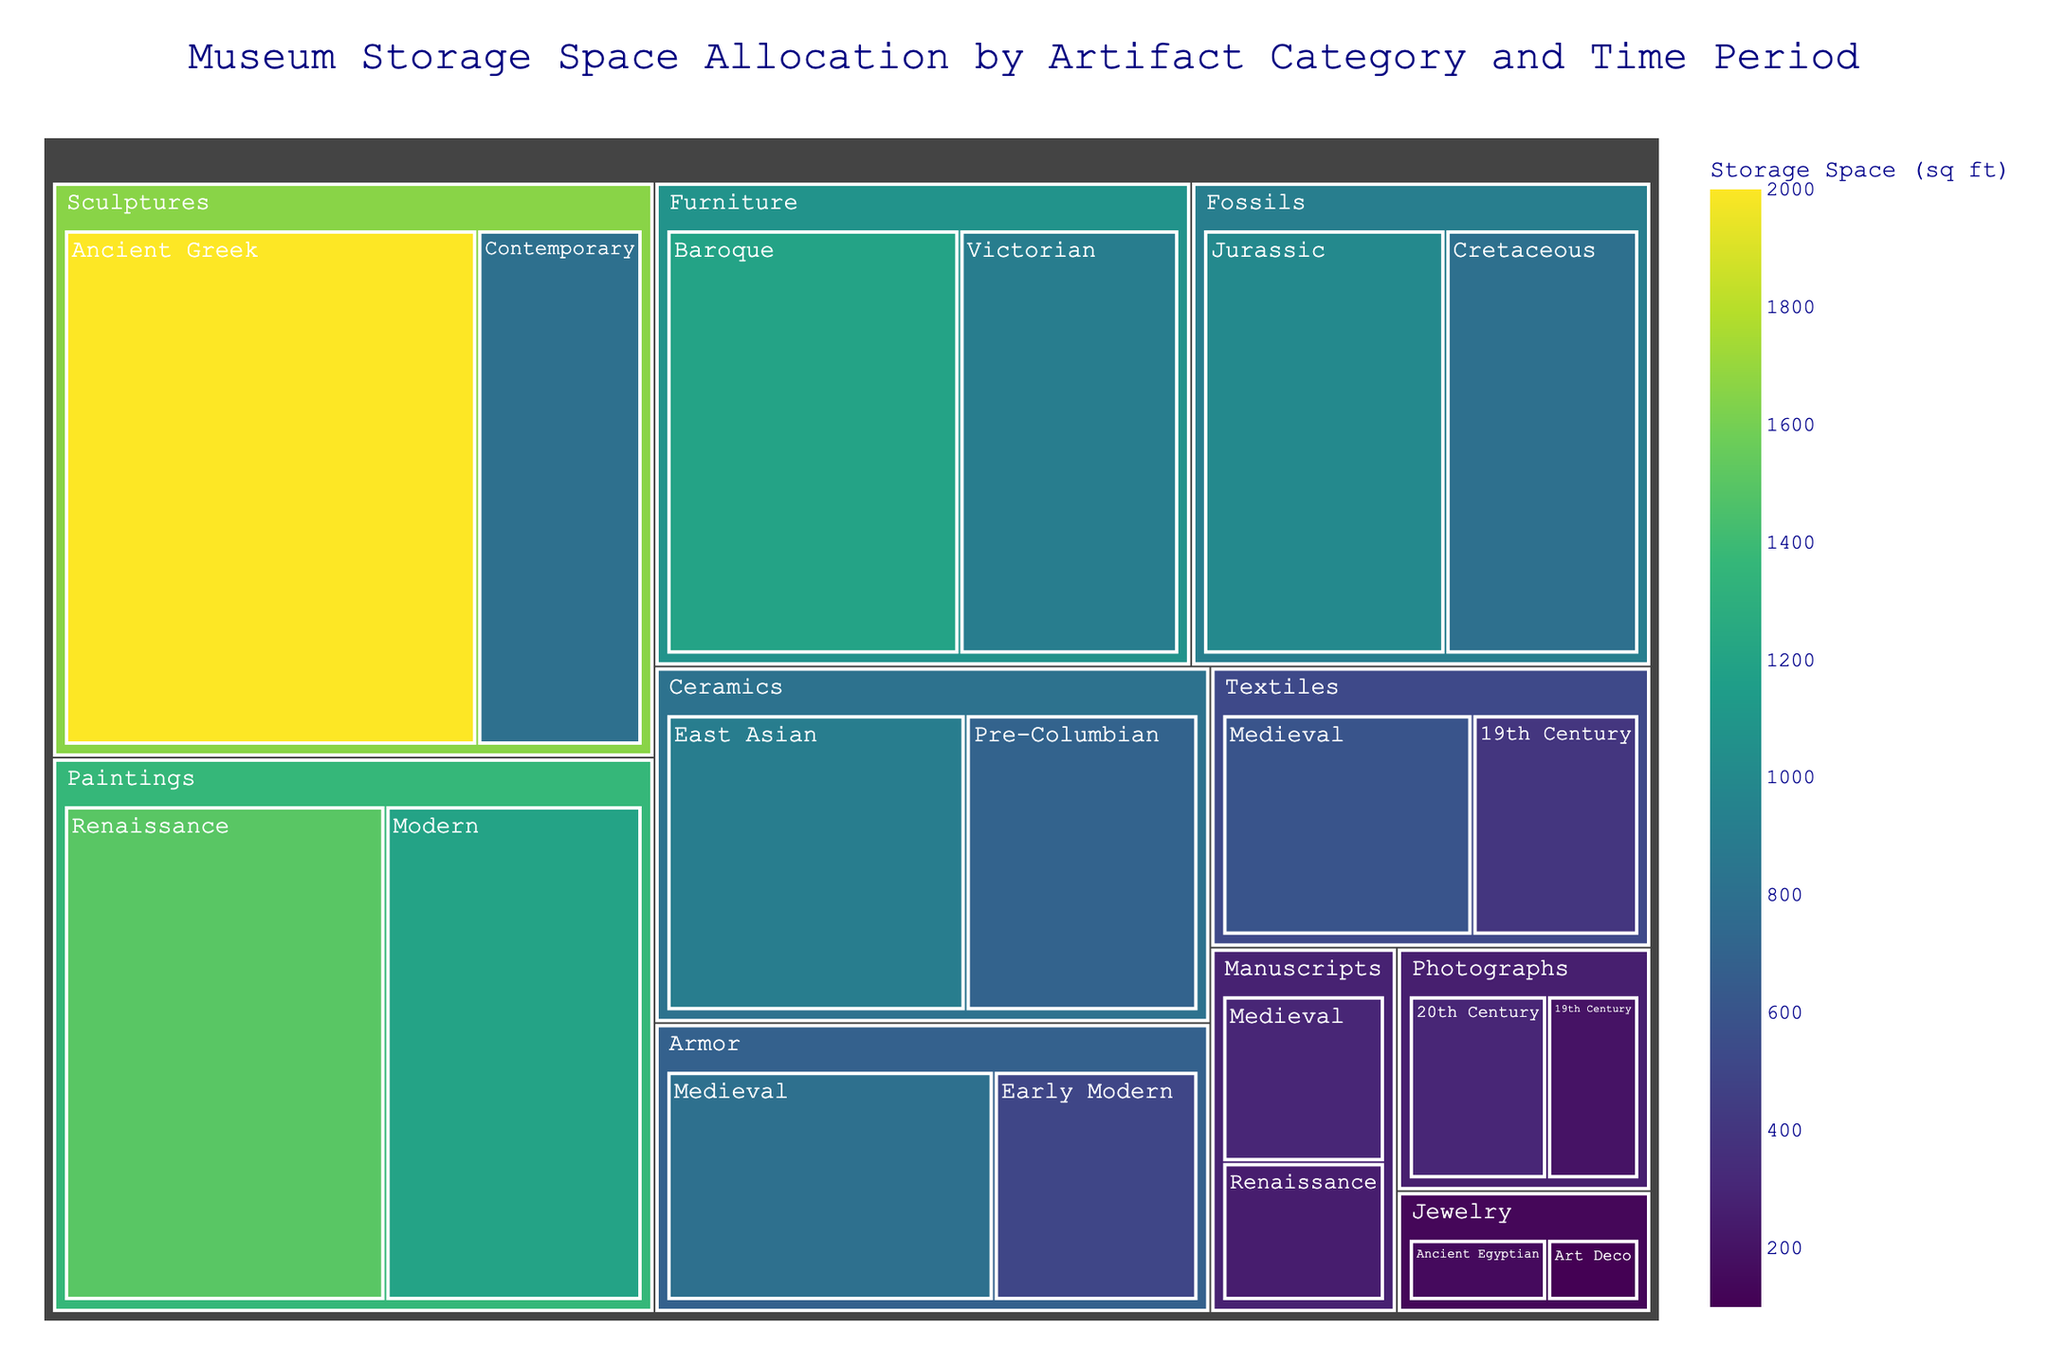Which category uses the largest storage space? To find the category using the largest storage space, look for the largest tile in the treemap. The "Sculptures" category stands out as it has the largest area combined from both "Ancient Greek" and "Contemporary" time periods.
Answer: Sculptures What is the title of this treemap? The title is typically located at the top-center of the treemap. In this case, it reads "Museum Storage Space Allocation by Artifact Category and Time Period".
Answer: Museum Storage Space Allocation by Artifact Category and Time Period Which category and time period combination has the smallest storage space allocation? To identify the smallest storage space allocation, look for the smallest tile in the treemap. The combination "Jewelry" and "Art Deco" stands out as the smallest.
Answer: Jewelry - Art Deco How does the storage space allocated to "Paintings" during the Renaissance compare to that of the "Modern" period? Compare the sizes of the tiles for "Paintings" in the Renaissance and Modern periods. The tile for "Paintings - Renaissance" is larger than "Paintings - Modern", indicating more storage space for the former.
Answer: Renaissance is larger What's the total storage space allocated to "Furniture"? The total storage space can be found by adding the storage space for each time period under "Furniture": Baroque (1200 sq ft) and Victorian (900 sq ft). The sum is 2100 sq ft.
Answer: 2100 sq ft Which category has the greatest variety of time periods? Count the different time periods listed under each category. The "Textiles" and "Paintings" categories each have two different time periods, but "Sculptures" also has two. Therefore, the answer is non-unique and can list any of these categories.
Answer: Textiles / Paintings / Sculptures How does the space allocated to "Fossils" compare between the Jurassic and Cretaceous periods? Compare the sizes of the tiles for "Fossils" in the Jurassic and Cretaceous periods. The Jurassic period has a larger tile, indicating greater storage space than the Cretaceous period.
Answer: Jurassic is larger What is the average storage space allocated per time period for "Ceramics"? To find the average, add the storage spaces for Ceramics (Pre-Columbian: 700 sq ft and East Asian: 900 sq ft) and divide by 2. The sum is 1600 sq ft, and the average is 1600/2 = 800 sq ft.
Answer: 800 sq ft Which century has more storage space allocated in the "Textiles" category: Medieval or 19th Century? Compare the storage space allocated to each time period under the "Textiles" category. The Medieval period (600 sq ft) has more allocated space than the 19th Century (400 sq ft).
Answer: Medieval How much more space is allocated to "Ancient Greek" Sculptures compared to "Contemporary" Sculptures? Subtract the storage space for Contemporary Sculptures (800 sq ft) from that of Ancient Greek Sculptures (2000 sq ft). The difference is 2000 - 800 = 1200 sq ft.
Answer: 1200 sq ft 